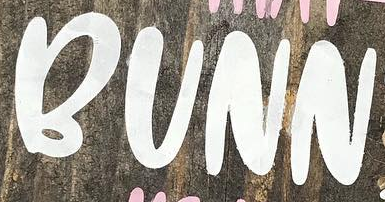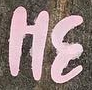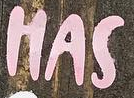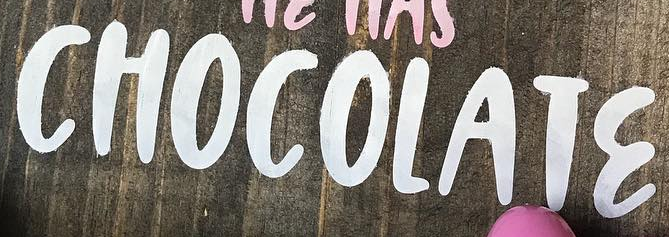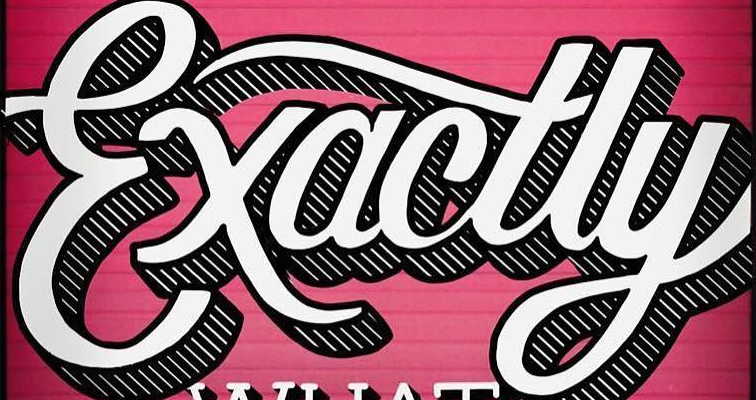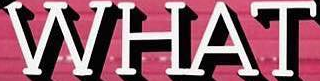What text appears in these images from left to right, separated by a semicolon? BUNN; HƐ; HAS; CHOCOLATƐ; Exactly; WHAT 